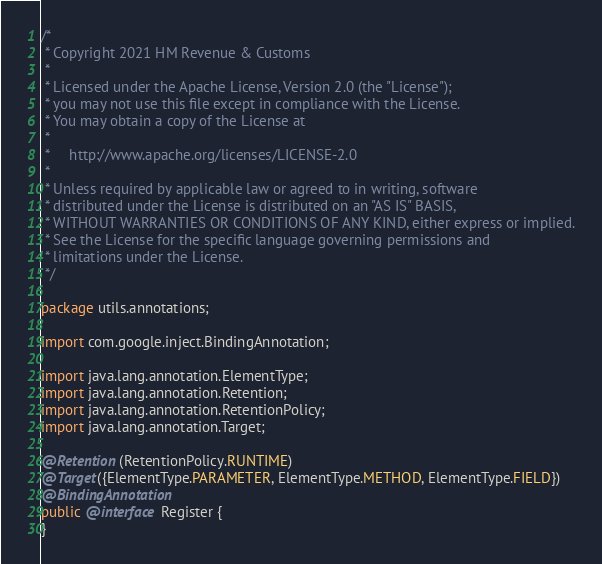Convert code to text. <code><loc_0><loc_0><loc_500><loc_500><_Java_>/*
 * Copyright 2021 HM Revenue & Customs
 *
 * Licensed under the Apache License, Version 2.0 (the "License");
 * you may not use this file except in compliance with the License.
 * You may obtain a copy of the License at
 *
 *     http://www.apache.org/licenses/LICENSE-2.0
 *
 * Unless required by applicable law or agreed to in writing, software
 * distributed under the License is distributed on an "AS IS" BASIS,
 * WITHOUT WARRANTIES OR CONDITIONS OF ANY KIND, either express or implied.
 * See the License for the specific language governing permissions and
 * limitations under the License.
 */

package utils.annotations;

import com.google.inject.BindingAnnotation;

import java.lang.annotation.ElementType;
import java.lang.annotation.Retention;
import java.lang.annotation.RetentionPolicy;
import java.lang.annotation.Target;

@Retention(RetentionPolicy.RUNTIME)
@Target({ElementType.PARAMETER, ElementType.METHOD, ElementType.FIELD})
@BindingAnnotation
public @interface Register {
}
</code> 